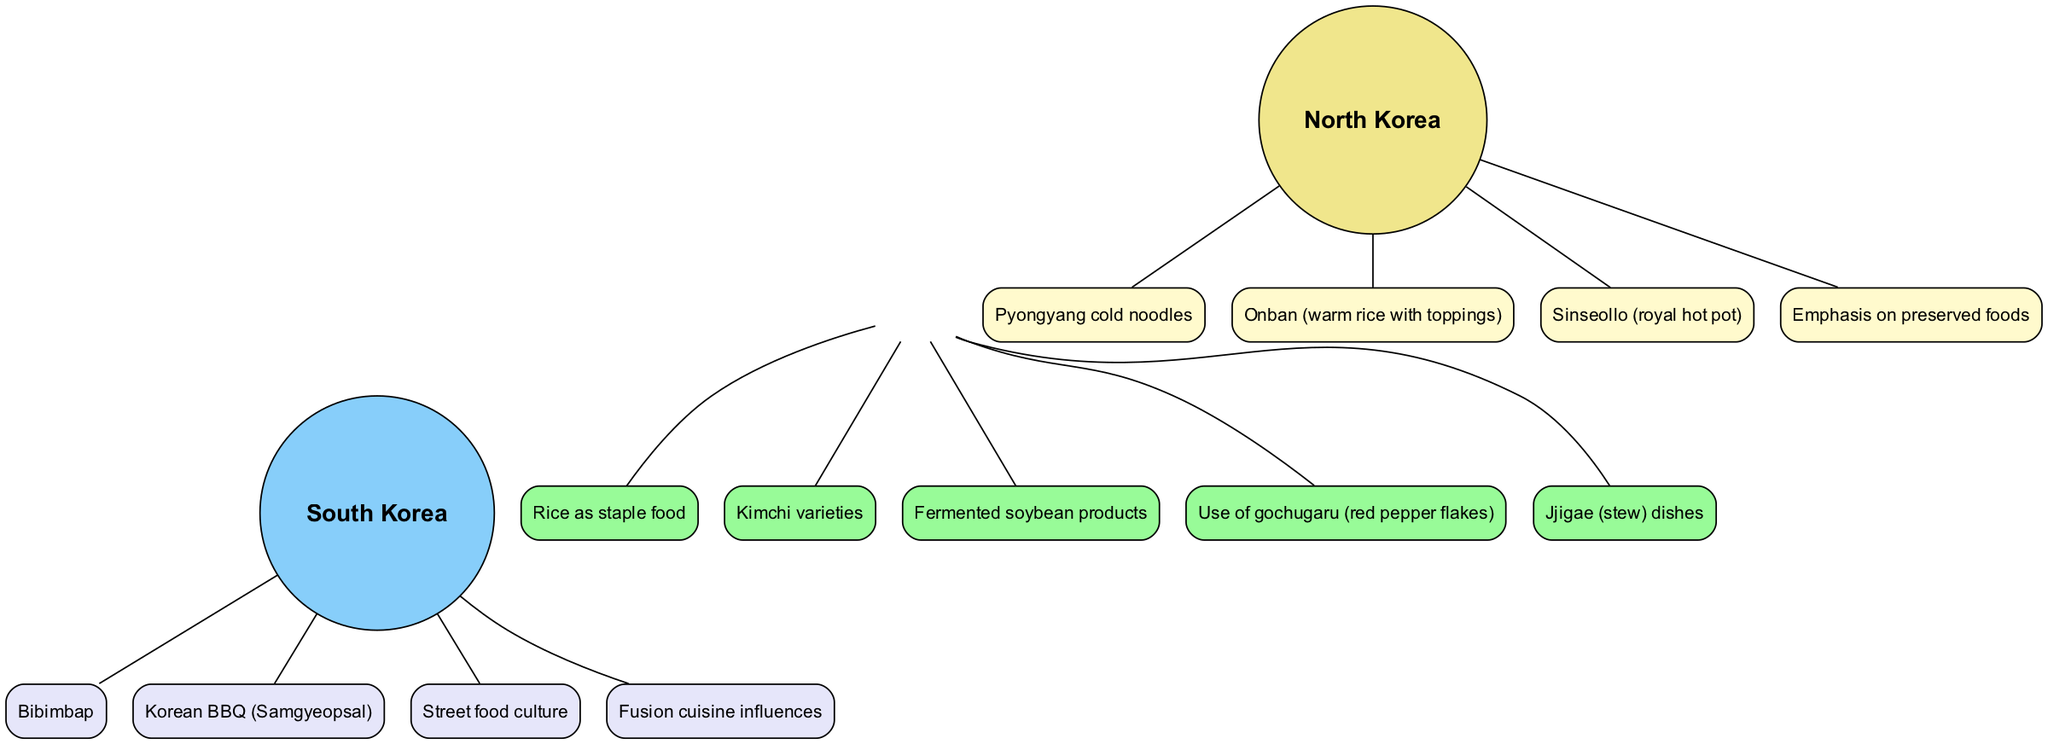What are the unique dishes from North Korea? The diagram lists four unique dishes in the North Korea section; these are Pyongyang cold noodles, Onban, Sinseollo, and an emphasis on preserved foods.
Answer: Pyongyang cold noodles, Onban, Sinseollo, preserved foods How many unique characteristics does South Korea have? The South Korea section specifies four unique characteristics, which include Bibimbap, Korean BBQ, street food culture, and fusion cuisine influences.
Answer: 4 What is a shared element between North and South Korea? The diagram shows several shared elements, one of which is rice as a staple food, which is defined in the shared section.
Answer: Rice as staple food Which unique dish is a royal hot pot from North Korea? The unique dish labeled as Sinseollo is specified in the North Korea section, indicating its significance and uniqueness.
Answer: Sinseollo Which element of cuisine indicates a street food culture unique to South Korea? The diagram highlights street food culture specifically as a unique element of South Korean cuisine, distinguishing it from the North.
Answer: Street food culture What color represents shared elements in the diagram? The shared elements section is color-coded with light green, as indicated in the visual representation of the diagram.
Answer: Light green How does the emphasis on preserved foods in North Korea compare to South Korean cuisine? The diagram illustrates that preserved foods are unique to North Korea, while South Korea emphasizes vibrant dishes like Korean BBQ and street food, highlighting a notable contrast.
Answer: Unique to North Korea How many shared elements are listed in the diagram? The diagram lists five specific shared elements, which include rice, kimchi varieties, fermented soybean products, gochugaru, and jjigae dishes.
Answer: 5 What is the unique South Korean dish that features a mix of ingredients and is often served in a bowl? Bibimbap is the unique South Korean dish highlighted in the South Korea section, indicating its blending of various ingredients.
Answer: Bibimbap 